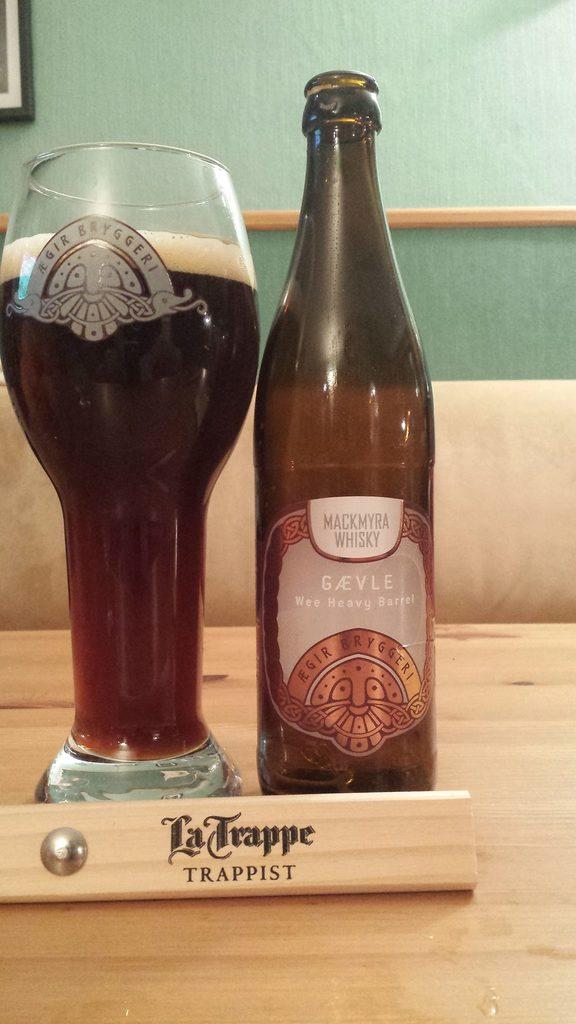<image>
Give a short and clear explanation of the subsequent image. A large glass is next to a bottle of Mackmyra whisky. 